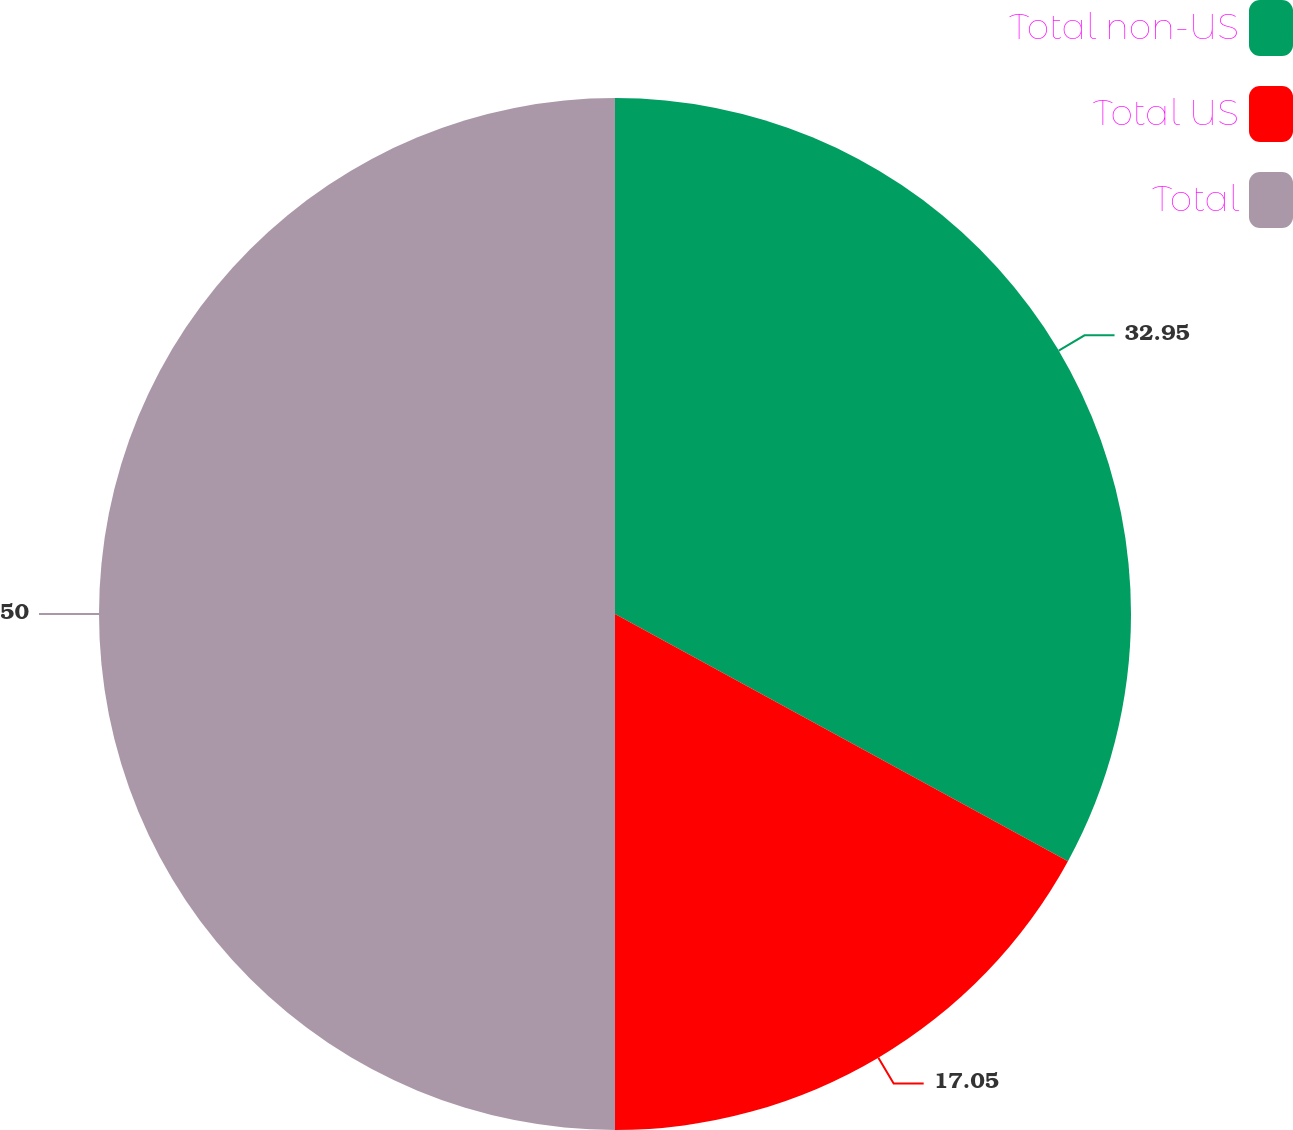<chart> <loc_0><loc_0><loc_500><loc_500><pie_chart><fcel>Total non-US<fcel>Total US<fcel>Total<nl><fcel>32.95%<fcel>17.05%<fcel>50.0%<nl></chart> 